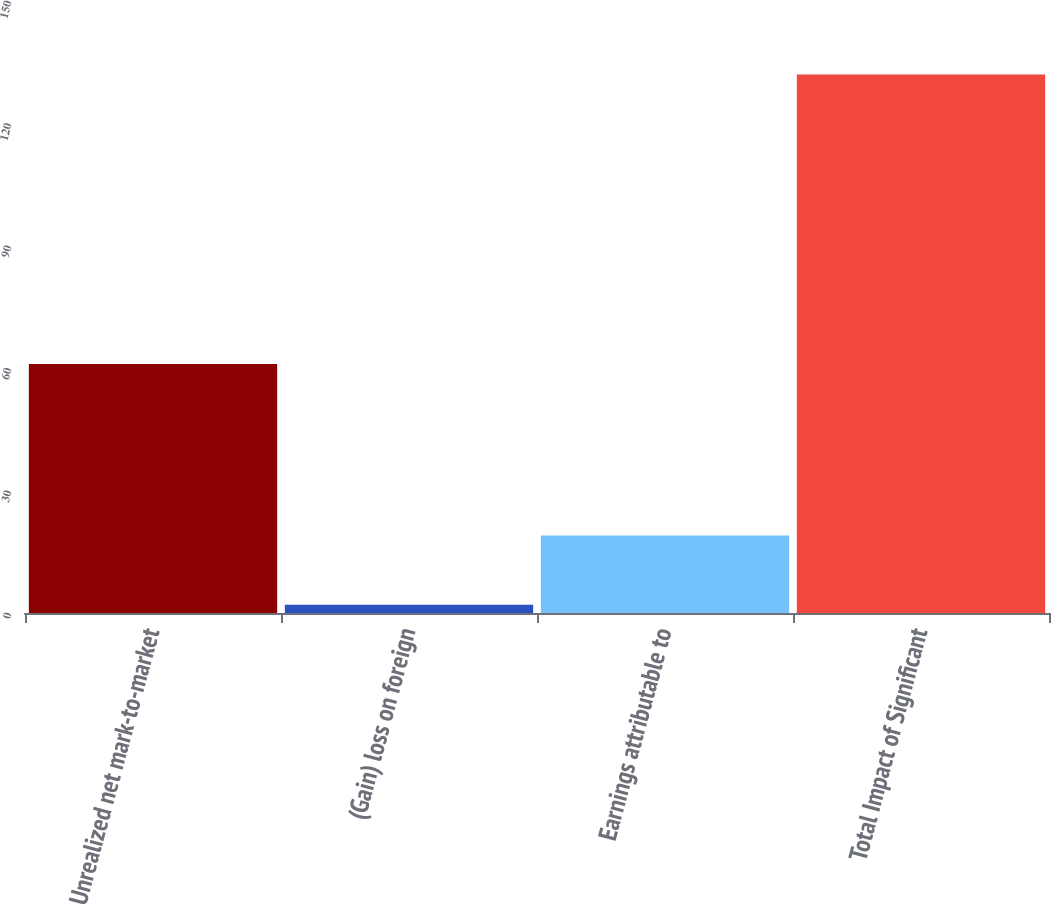<chart> <loc_0><loc_0><loc_500><loc_500><bar_chart><fcel>Unrealized net mark-to-market<fcel>(Gain) loss on foreign<fcel>Earnings attributable to<fcel>Total Impact of Significant<nl><fcel>61<fcel>2<fcel>19<fcel>132<nl></chart> 